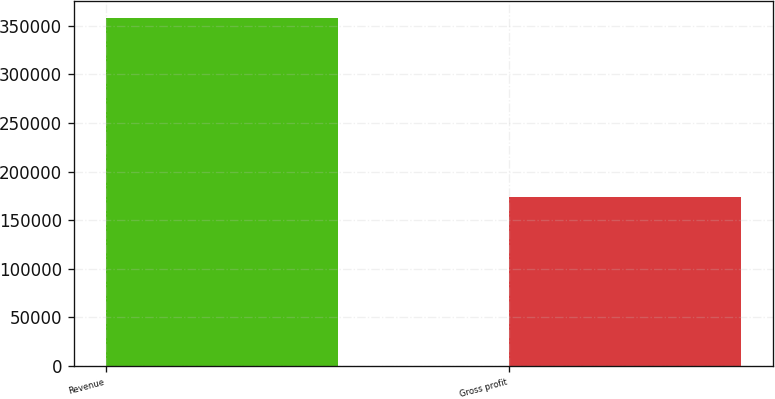Convert chart to OTSL. <chart><loc_0><loc_0><loc_500><loc_500><bar_chart><fcel>Revenue<fcel>Gross profit<nl><fcel>357978<fcel>173395<nl></chart> 